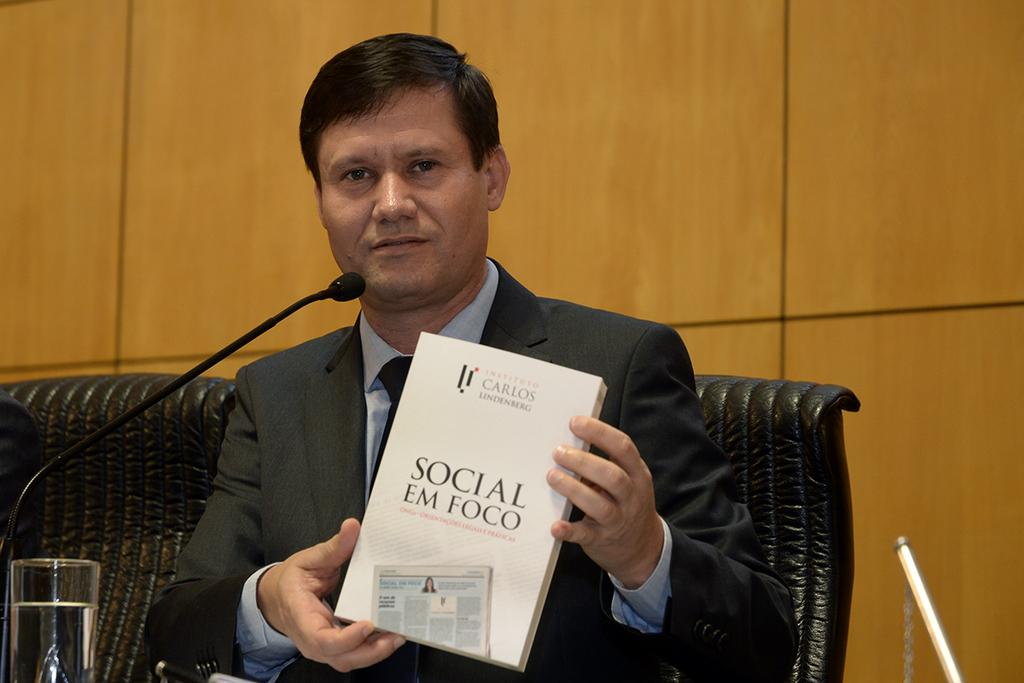<image>
Summarize the visual content of the image. A man holding a book entitled Social Em Foco. 